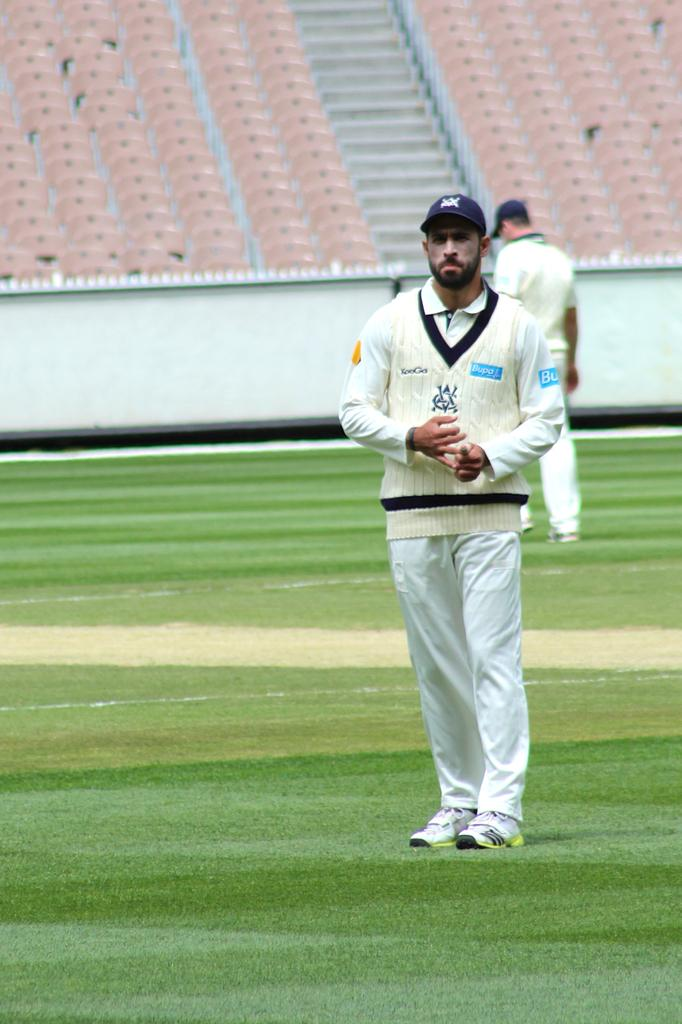Provide a one-sentence caption for the provided image. The light blue advertising on the mans shirt is for Bupa. 